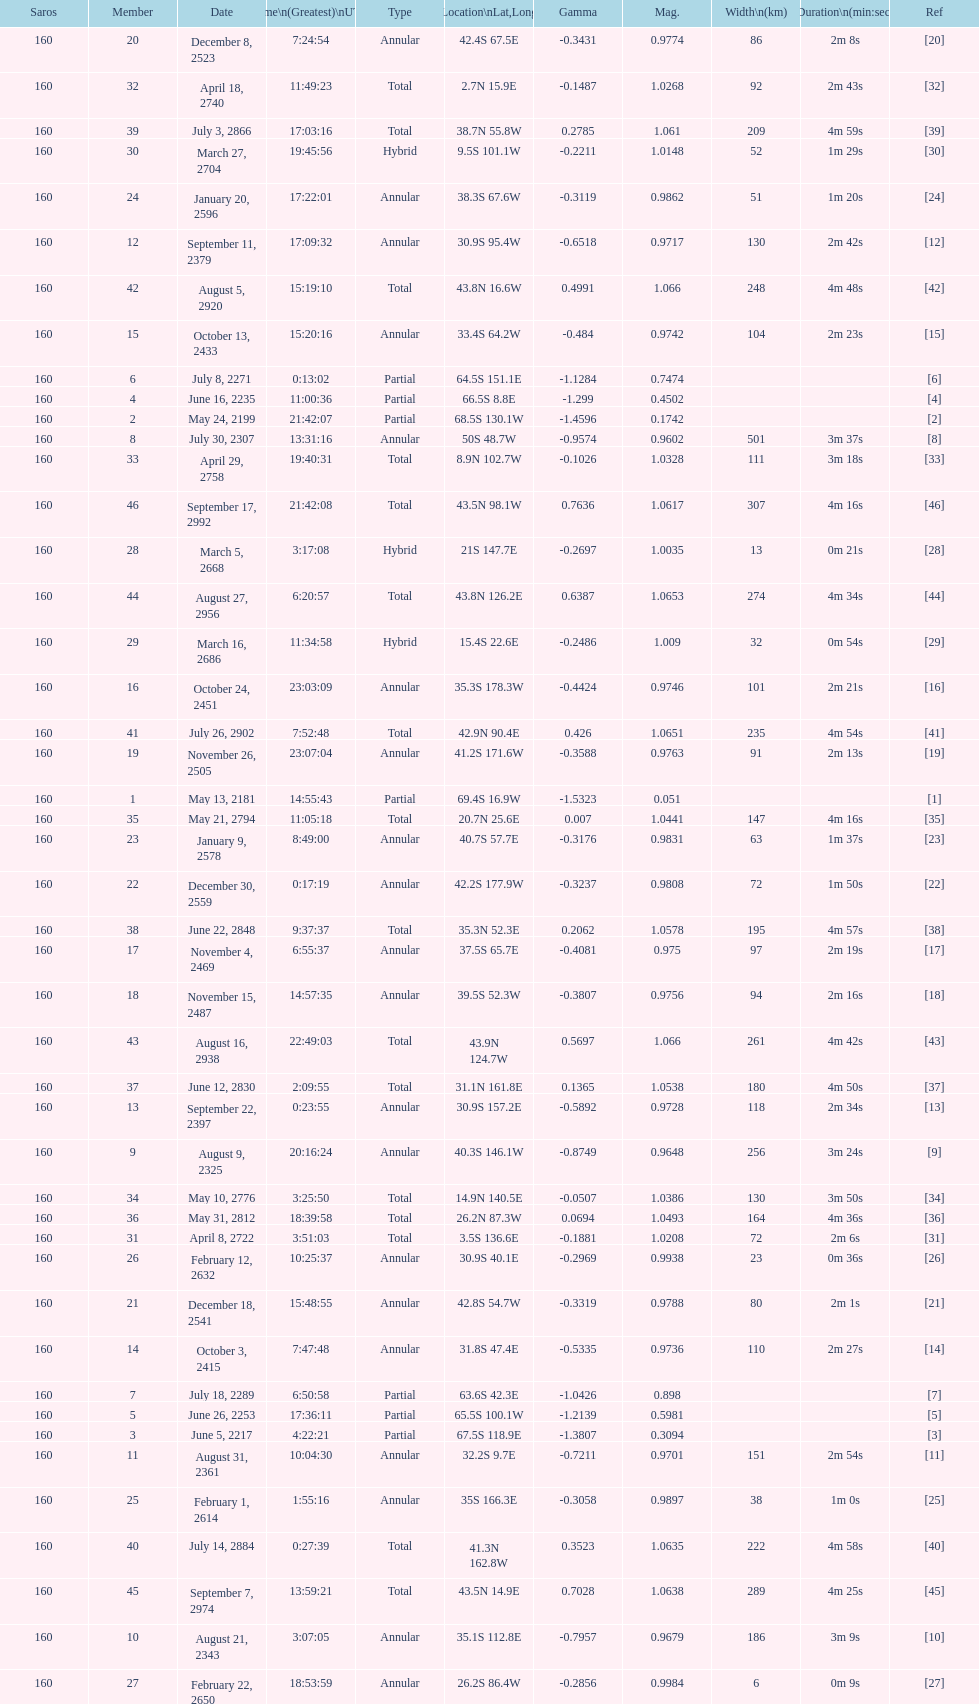When did the first solar saros with a magnitude of greater than 1.00 occur? March 5, 2668. 